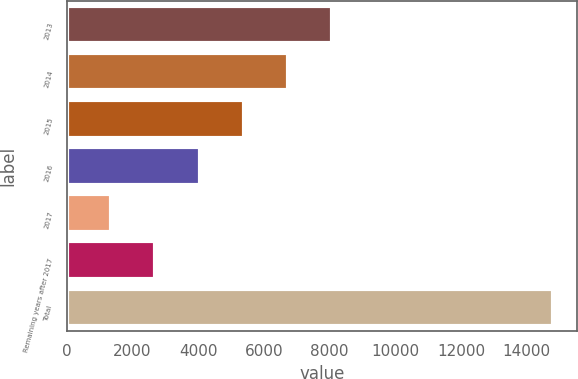<chart> <loc_0><loc_0><loc_500><loc_500><bar_chart><fcel>2013<fcel>2014<fcel>2015<fcel>2016<fcel>2017<fcel>Remaining years after 2017<fcel>Total<nl><fcel>8076<fcel>6730.2<fcel>5384.4<fcel>4038.6<fcel>1347<fcel>2692.8<fcel>14805<nl></chart> 